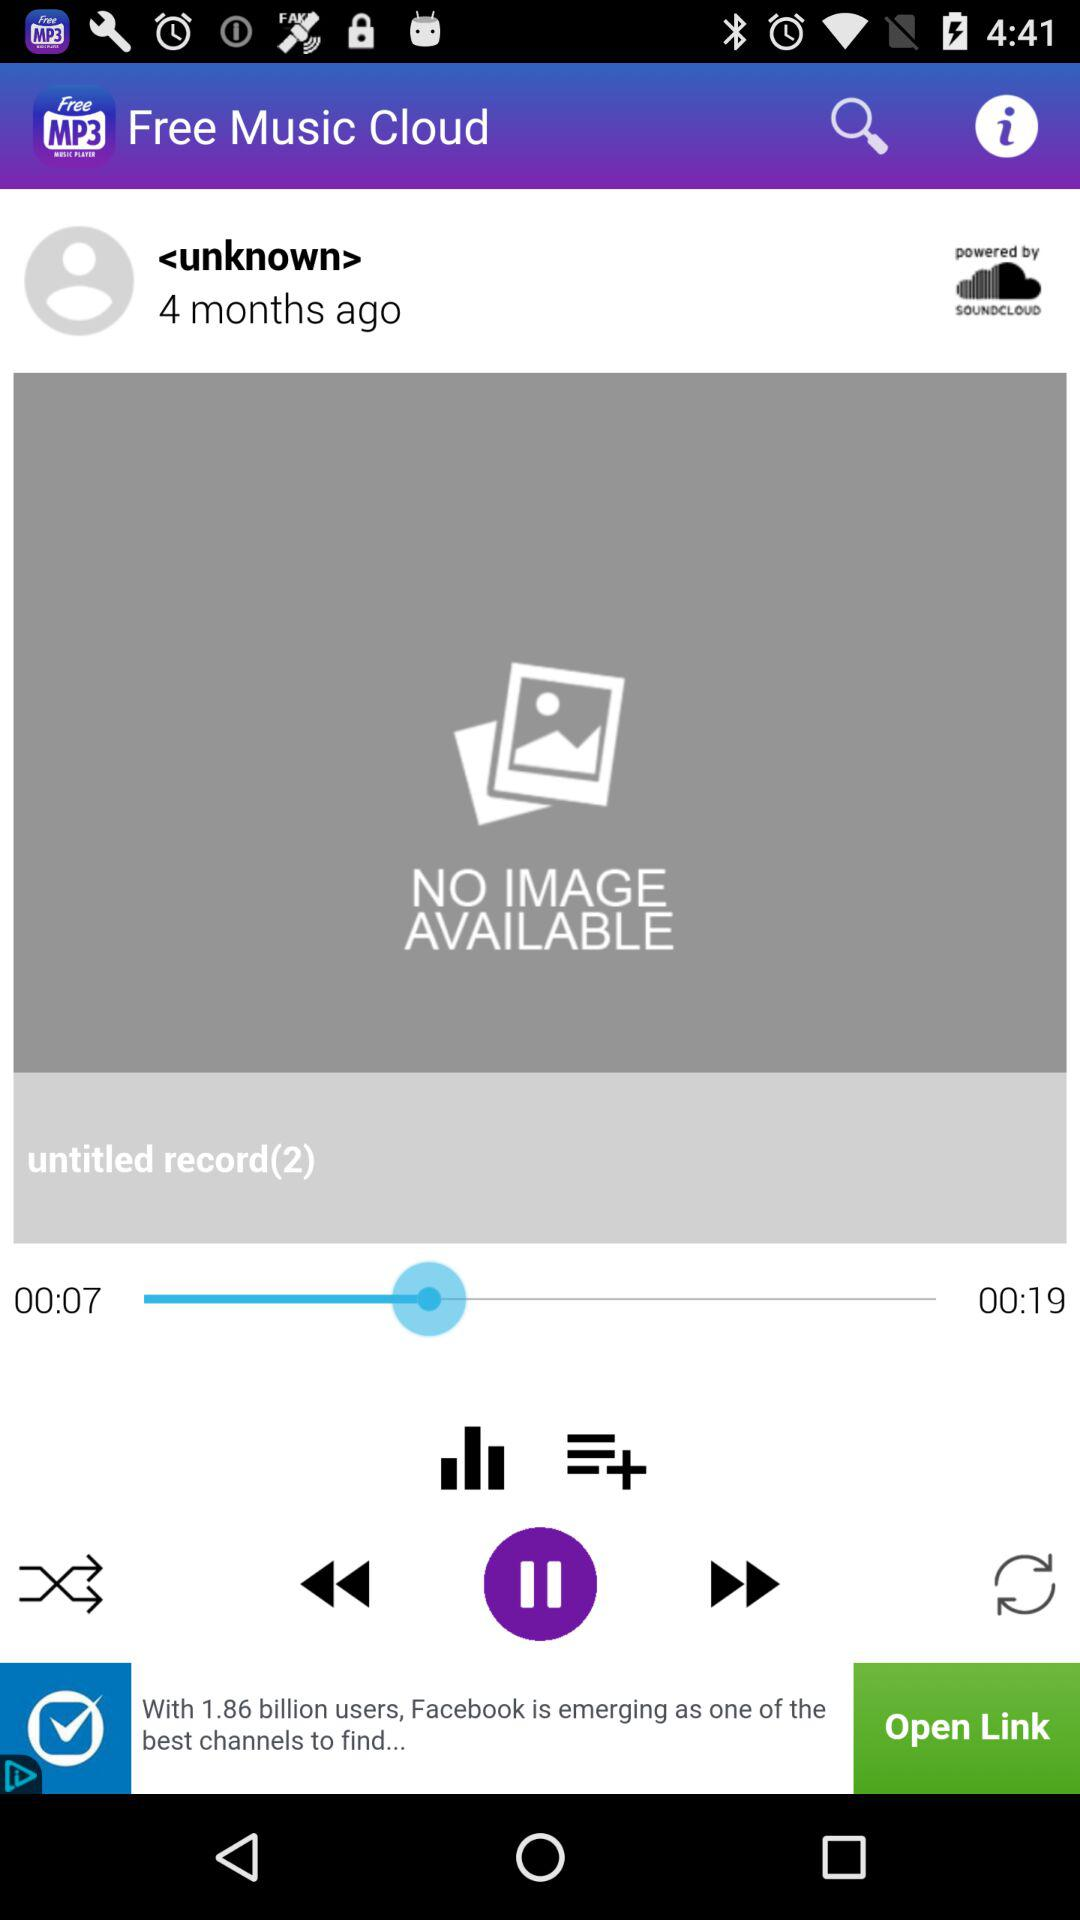For how long has the song been played? The song has been played for 7 seconds. 